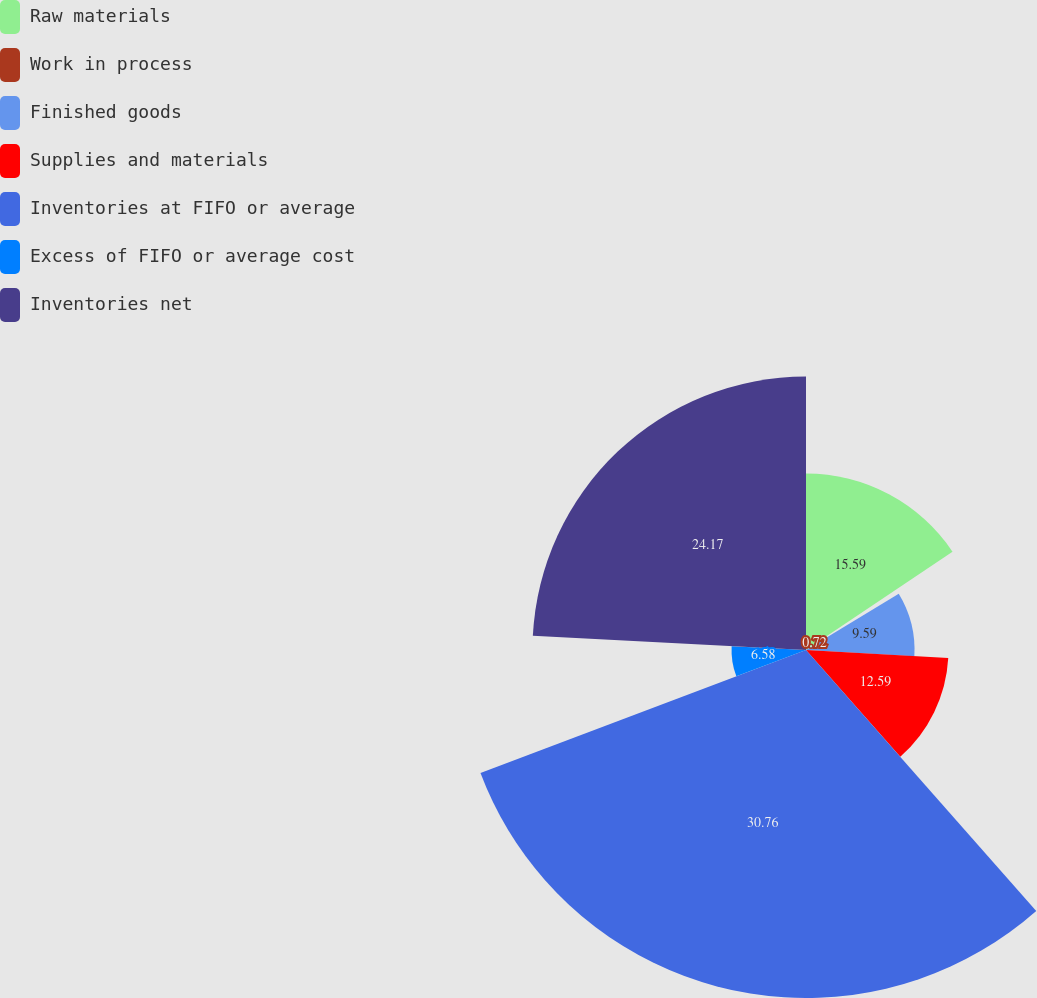Convert chart to OTSL. <chart><loc_0><loc_0><loc_500><loc_500><pie_chart><fcel>Raw materials<fcel>Work in process<fcel>Finished goods<fcel>Supplies and materials<fcel>Inventories at FIFO or average<fcel>Excess of FIFO or average cost<fcel>Inventories net<nl><fcel>15.59%<fcel>0.72%<fcel>9.59%<fcel>12.59%<fcel>30.75%<fcel>6.58%<fcel>24.17%<nl></chart> 